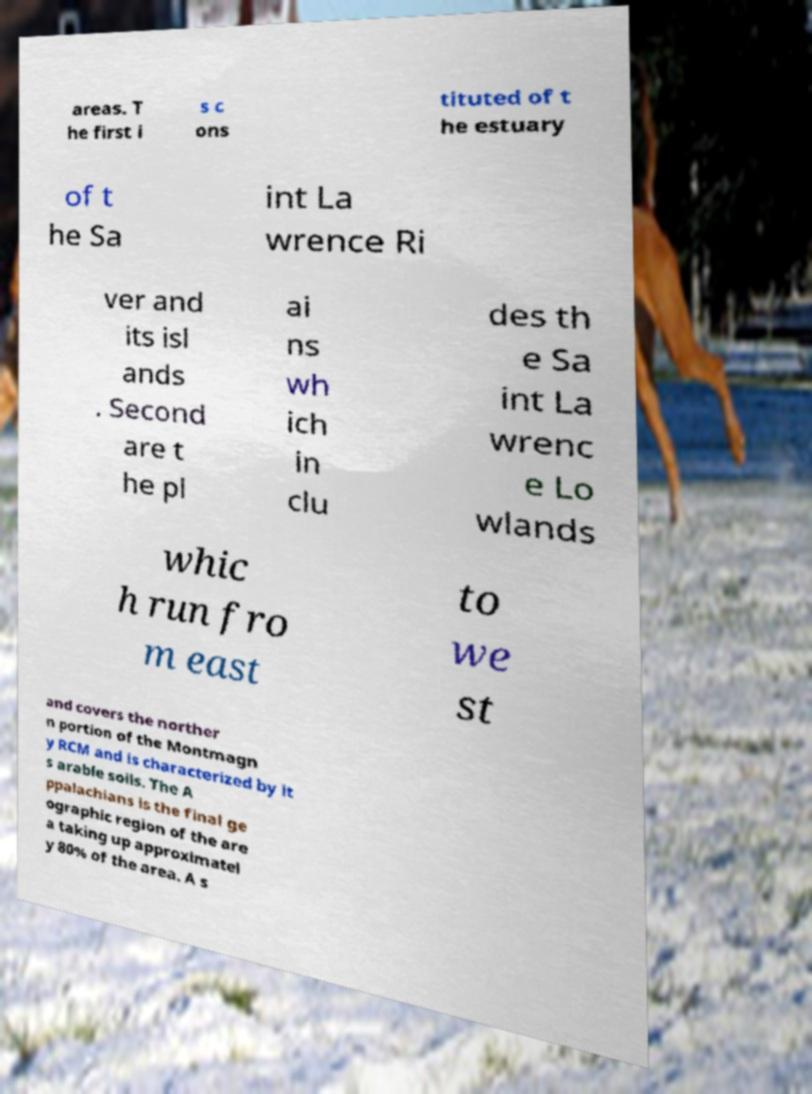I need the written content from this picture converted into text. Can you do that? areas. T he first i s c ons tituted of t he estuary of t he Sa int La wrence Ri ver and its isl ands . Second are t he pl ai ns wh ich in clu des th e Sa int La wrenc e Lo wlands whic h run fro m east to we st and covers the norther n portion of the Montmagn y RCM and is characterized by it s arable soils. The A ppalachians is the final ge ographic region of the are a taking up approximatel y 80% of the area. A s 